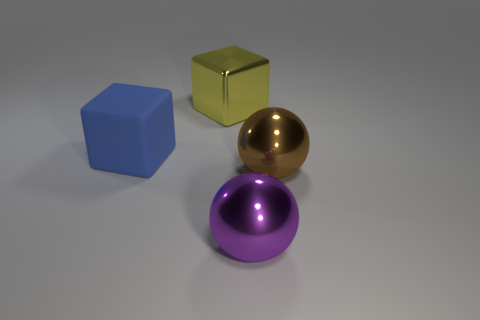There is a large metallic block behind the large object left of the large shiny object left of the purple thing; what is its color?
Make the answer very short. Yellow. What shape is the metal object that is to the right of the big purple metal thing in front of the large brown thing?
Provide a short and direct response. Sphere. Is the number of purple metal things on the left side of the purple metallic thing greater than the number of purple metallic balls?
Keep it short and to the point. No. There is a big thing that is behind the large blue rubber cube; is its shape the same as the big brown object?
Keep it short and to the point. No. Are there any large purple things that have the same shape as the brown metal thing?
Your answer should be compact. Yes. How many objects are big metal spheres that are to the left of the brown thing or large yellow shiny cubes?
Give a very brief answer. 2. Is the number of purple metal things greater than the number of metal things?
Give a very brief answer. No. Is there a brown metal object that has the same size as the brown ball?
Offer a very short reply. No. What number of things are large objects behind the big brown metallic ball or balls that are behind the purple thing?
Your answer should be compact. 3. The ball left of the brown ball in front of the large blue object is what color?
Ensure brevity in your answer.  Purple. 